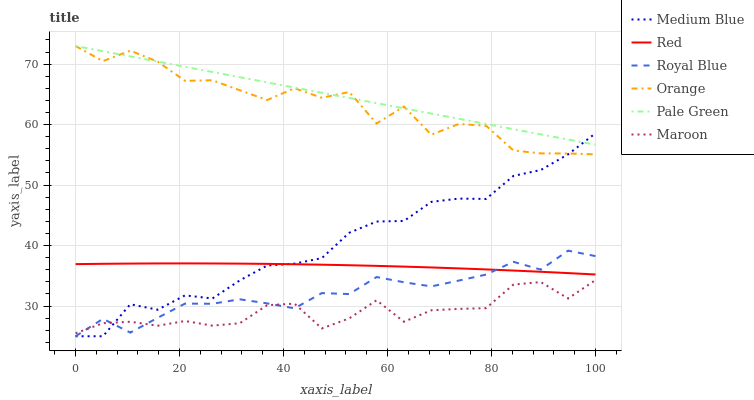Does Maroon have the minimum area under the curve?
Answer yes or no. Yes. Does Pale Green have the maximum area under the curve?
Answer yes or no. Yes. Does Royal Blue have the minimum area under the curve?
Answer yes or no. No. Does Royal Blue have the maximum area under the curve?
Answer yes or no. No. Is Pale Green the smoothest?
Answer yes or no. Yes. Is Orange the roughest?
Answer yes or no. Yes. Is Maroon the smoothest?
Answer yes or no. No. Is Maroon the roughest?
Answer yes or no. No. Does Maroon have the lowest value?
Answer yes or no. No. Does Orange have the highest value?
Answer yes or no. Yes. Does Royal Blue have the highest value?
Answer yes or no. No. Is Royal Blue less than Orange?
Answer yes or no. Yes. Is Orange greater than Royal Blue?
Answer yes or no. Yes. Does Pale Green intersect Orange?
Answer yes or no. Yes. Is Pale Green less than Orange?
Answer yes or no. No. Is Pale Green greater than Orange?
Answer yes or no. No. Does Royal Blue intersect Orange?
Answer yes or no. No. 